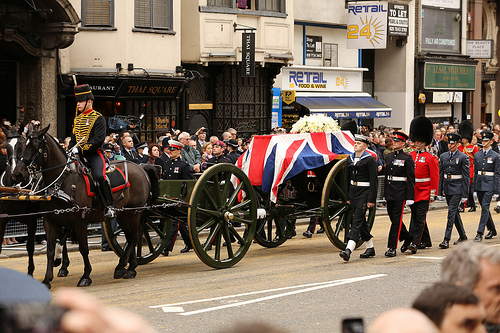Describe the attire of the participants in the procession. The participants in the procession are wearing formal, ceremonial uniforms. Some are seen in military dress with medals and insignia, while others are in more elaborate dress that includes colorful sashes, tall hats, and detailed jackets. The uniformity and precision of their attire further emphasize the formal and solemn nature of the event. What might be the significance of the tall hats worn by some participants? The tall hats worn by some participants, likely bearskin or similar, are often a part of traditional military dress and are symbolic of an elite ceremonial unit. They signify formality, respect, and honor, often seen in grand state occasions and parades. Their presence adds to the solemnity and grandeur of the event. Can you imagine a detailed backstory for one of the onlookers? Certainly! One of the onlookers could be an older gentleman wearing a fedora hat, with a solemn expression. He might be a retired veteran who served in the sharegpt4v/same regiment that is now part of the procession. His presence at the ceremony is a mix of pride and nostalgia as he remembers his own days in service and honors the traditions he once was a part of. He likely moved to the city decades ago and told stories of his service to his children and grandchildren, making this event a personal commemoration of his life's journey and service to his country. What kind of event could lead to such a grand procession in a bustling city? Such a grand procession in a bustling city could occur during a state funeral for a prominent national figure, a major national holiday celebration, a significant historical commemoration, or the coronation of a new monarch. These events often draw large crowds, involve elaborate ceremonies, and feature organized parades to honor the importance of the occasion in a nation's history and culture. 